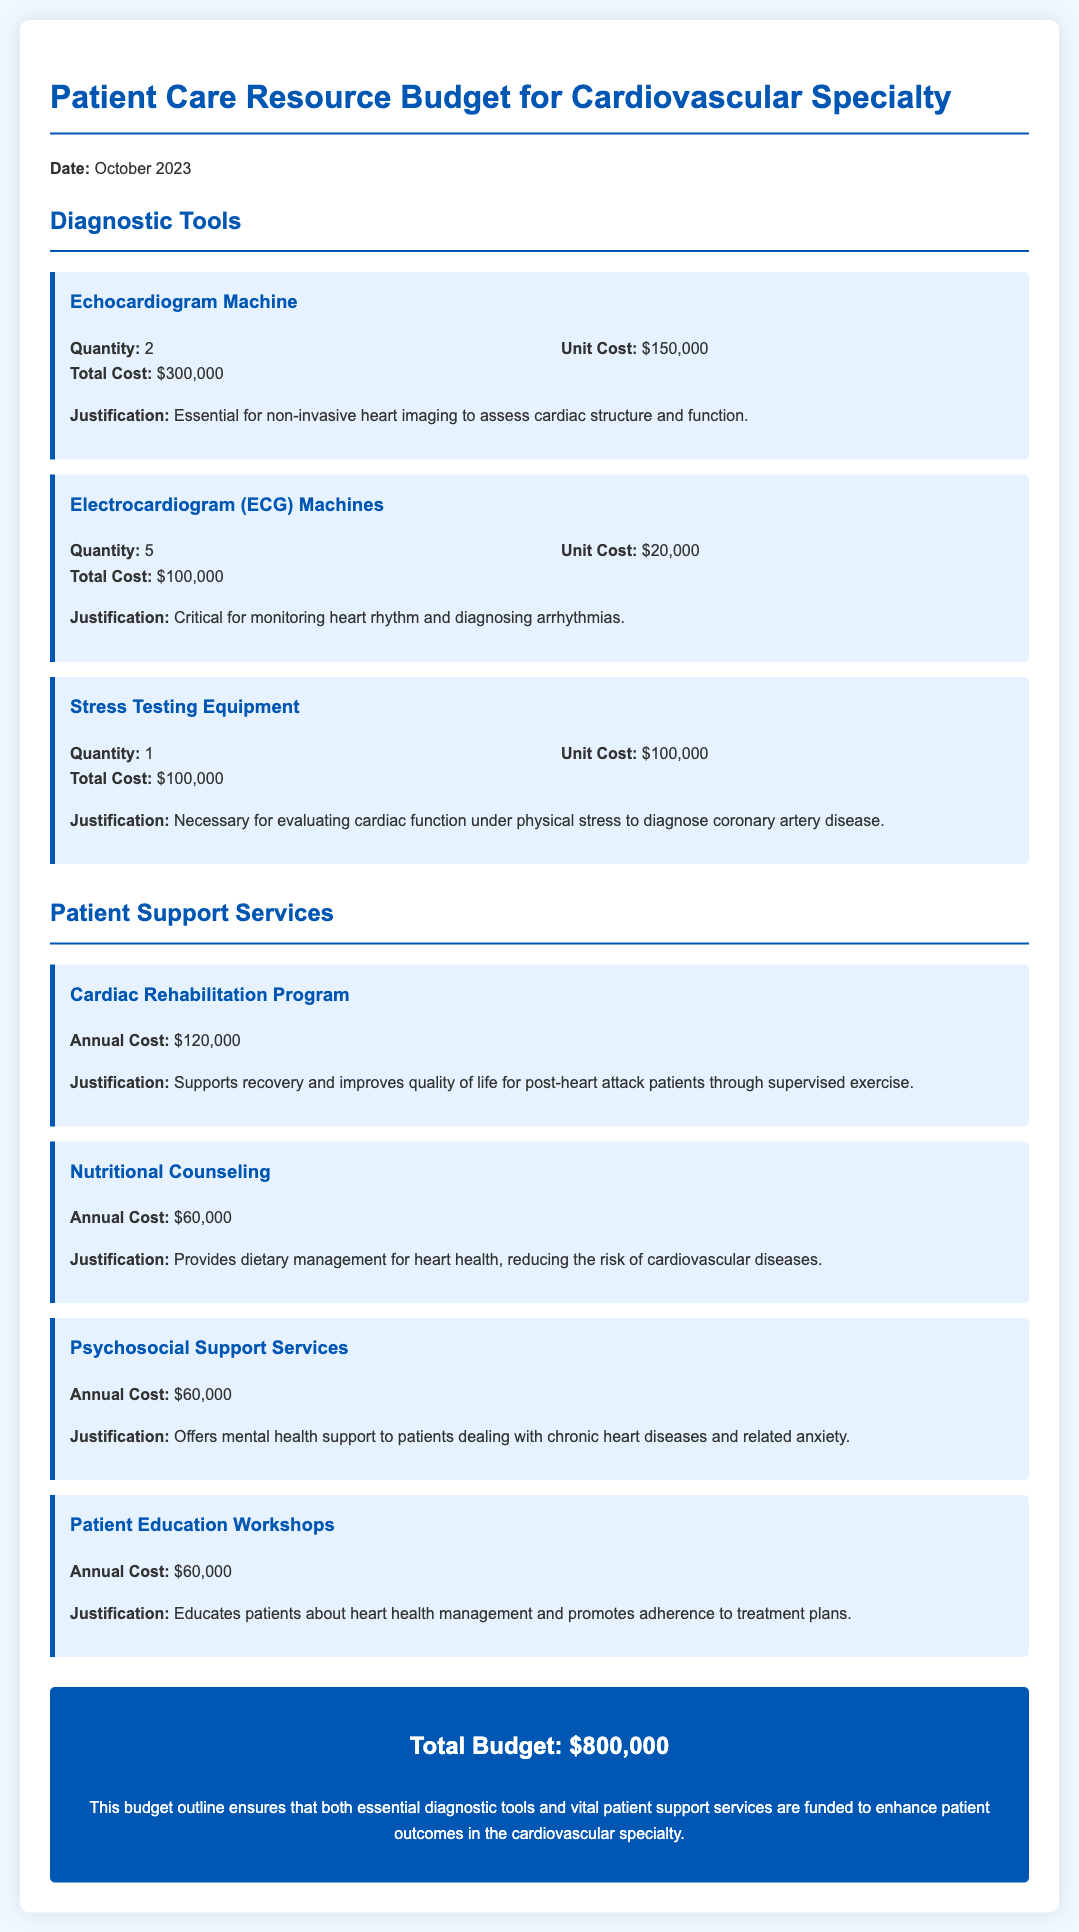What is the total cost for the Echocardiogram Machines? The total cost for the Echocardiogram Machines is calculated as 2 machines at $150,000 each, resulting in a total of $300,000.
Answer: $300,000 How many Electrocardiogram (ECG) Machines are allocated? The document states that 5 Electrocardiogram (ECG) Machines are allocated for the budget.
Answer: 5 What is the annual cost of the Cardiac Rehabilitation Program? The annual cost specified in the document for the Cardiac Rehabilitation Program is $120,000.
Answer: $120,000 What is the unit cost of the Stress Testing Equipment? The document lists the unit cost of the Stress Testing Equipment as $100,000.
Answer: $100,000 What is the total budget for patient care resources? The total budget amount presented in the document for patient care resources is $800,000.
Answer: $800,000 What is the justification for the Nutritional Counseling service? The document justifies Nutritional Counseling as providing dietary management for heart health, reducing cardiovascular disease risk.
Answer: Provides dietary management for heart health How many units of Stress Testing Equipment are being funded? According to the document, there is 1 unit of Stress Testing Equipment being funded.
Answer: 1 What service is offered for mental health support? The document specifies that Psychosocial Support Services offer mental health support to patients.
Answer: Psychosocial Support Services Which diagnostic tool is used for non-invasive heart imaging? The document states that the Echocardiogram Machine is essential for non-invasive heart imaging.
Answer: Echocardiogram Machine 